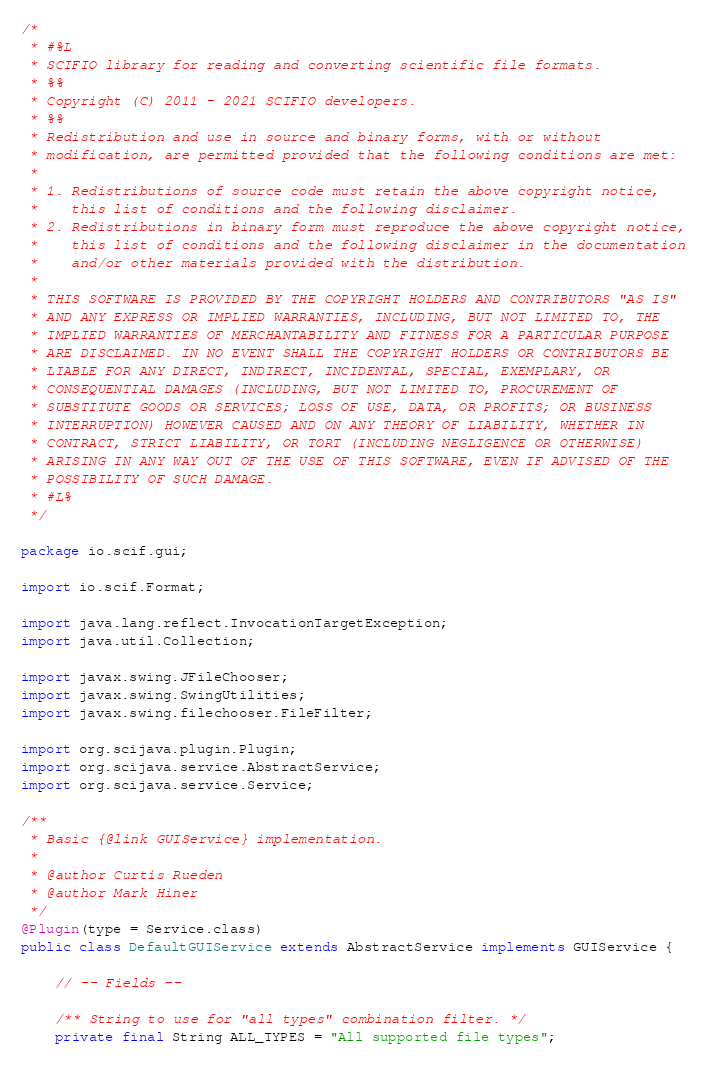Convert code to text. <code><loc_0><loc_0><loc_500><loc_500><_Java_>/*
 * #%L
 * SCIFIO library for reading and converting scientific file formats.
 * %%
 * Copyright (C) 2011 - 2021 SCIFIO developers.
 * %%
 * Redistribution and use in source and binary forms, with or without
 * modification, are permitted provided that the following conditions are met:
 * 
 * 1. Redistributions of source code must retain the above copyright notice,
 *    this list of conditions and the following disclaimer.
 * 2. Redistributions in binary form must reproduce the above copyright notice,
 *    this list of conditions and the following disclaimer in the documentation
 *    and/or other materials provided with the distribution.
 * 
 * THIS SOFTWARE IS PROVIDED BY THE COPYRIGHT HOLDERS AND CONTRIBUTORS "AS IS"
 * AND ANY EXPRESS OR IMPLIED WARRANTIES, INCLUDING, BUT NOT LIMITED TO, THE
 * IMPLIED WARRANTIES OF MERCHANTABILITY AND FITNESS FOR A PARTICULAR PURPOSE
 * ARE DISCLAIMED. IN NO EVENT SHALL THE COPYRIGHT HOLDERS OR CONTRIBUTORS BE
 * LIABLE FOR ANY DIRECT, INDIRECT, INCIDENTAL, SPECIAL, EXEMPLARY, OR
 * CONSEQUENTIAL DAMAGES (INCLUDING, BUT NOT LIMITED TO, PROCUREMENT OF
 * SUBSTITUTE GOODS OR SERVICES; LOSS OF USE, DATA, OR PROFITS; OR BUSINESS
 * INTERRUPTION) HOWEVER CAUSED AND ON ANY THEORY OF LIABILITY, WHETHER IN
 * CONTRACT, STRICT LIABILITY, OR TORT (INCLUDING NEGLIGENCE OR OTHERWISE)
 * ARISING IN ANY WAY OUT OF THE USE OF THIS SOFTWARE, EVEN IF ADVISED OF THE
 * POSSIBILITY OF SUCH DAMAGE.
 * #L%
 */

package io.scif.gui;

import io.scif.Format;

import java.lang.reflect.InvocationTargetException;
import java.util.Collection;

import javax.swing.JFileChooser;
import javax.swing.SwingUtilities;
import javax.swing.filechooser.FileFilter;

import org.scijava.plugin.Plugin;
import org.scijava.service.AbstractService;
import org.scijava.service.Service;

/**
 * Basic {@link GUIService} implementation.
 *
 * @author Curtis Rueden
 * @author Mark Hiner
 */
@Plugin(type = Service.class)
public class DefaultGUIService extends AbstractService implements GUIService {

	// -- Fields --

	/** String to use for "all types" combination filter. */
	private final String ALL_TYPES = "All supported file types";
</code> 